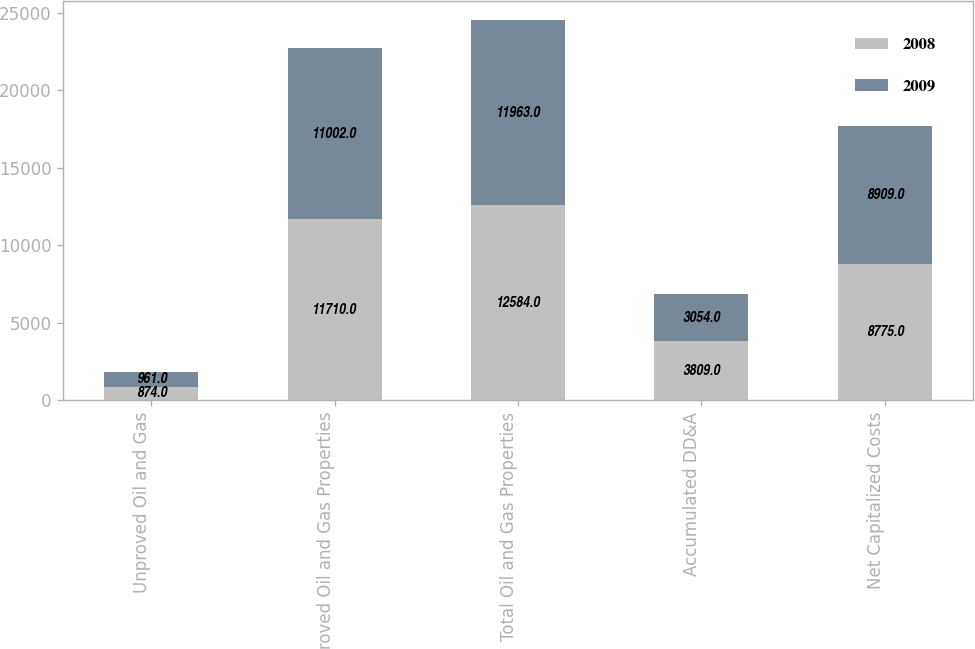Convert chart. <chart><loc_0><loc_0><loc_500><loc_500><stacked_bar_chart><ecel><fcel>Unproved Oil and Gas<fcel>Proved Oil and Gas Properties<fcel>Total Oil and Gas Properties<fcel>Accumulated DD&A<fcel>Net Capitalized Costs<nl><fcel>2008<fcel>874<fcel>11710<fcel>12584<fcel>3809<fcel>8775<nl><fcel>2009<fcel>961<fcel>11002<fcel>11963<fcel>3054<fcel>8909<nl></chart> 